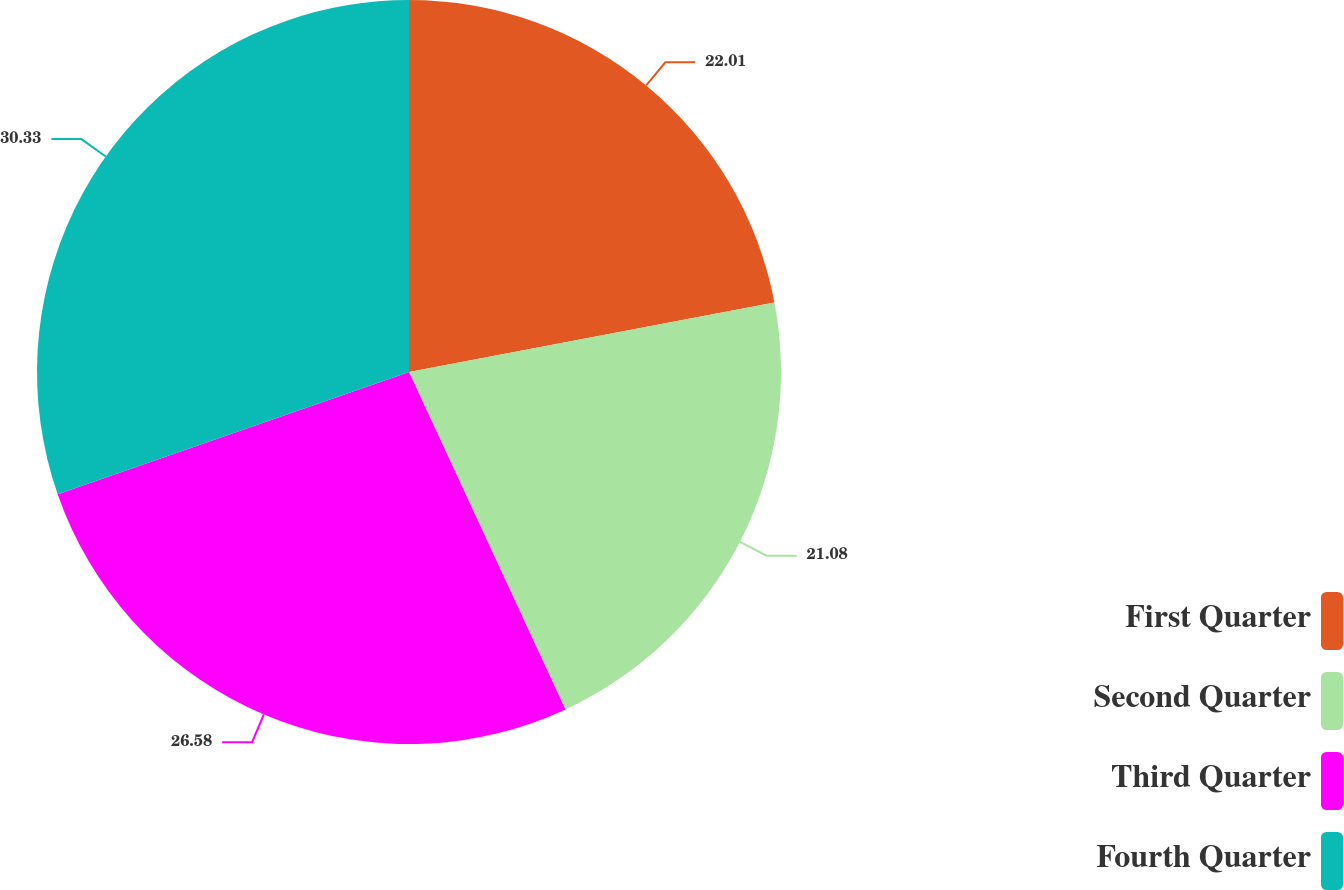<chart> <loc_0><loc_0><loc_500><loc_500><pie_chart><fcel>First Quarter<fcel>Second Quarter<fcel>Third Quarter<fcel>Fourth Quarter<nl><fcel>22.01%<fcel>21.08%<fcel>26.58%<fcel>30.33%<nl></chart> 